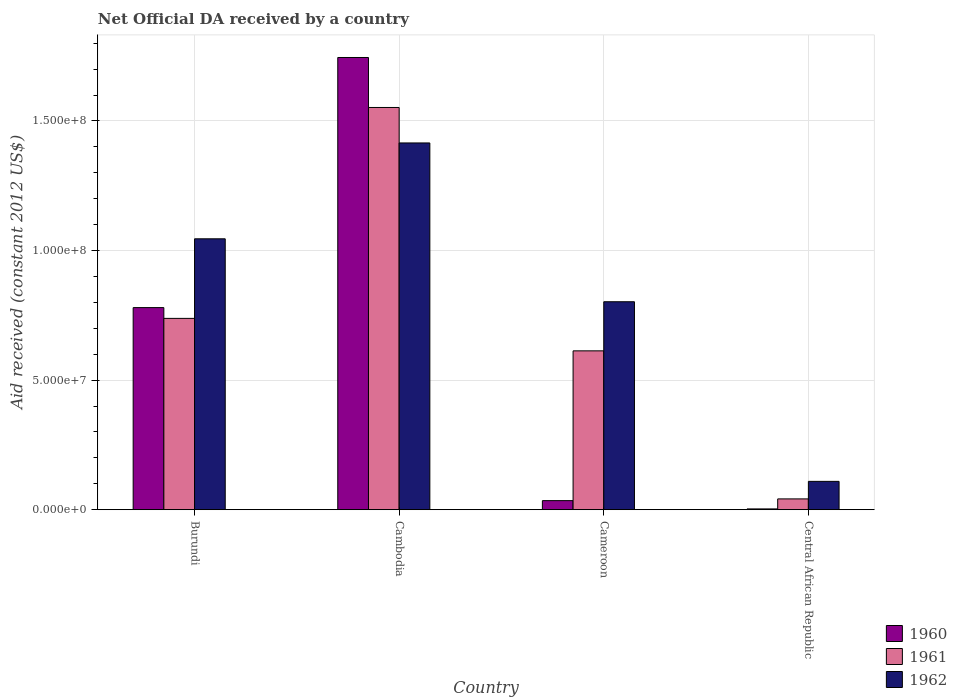Are the number of bars per tick equal to the number of legend labels?
Provide a short and direct response. Yes. What is the label of the 1st group of bars from the left?
Provide a short and direct response. Burundi. In how many cases, is the number of bars for a given country not equal to the number of legend labels?
Your answer should be compact. 0. What is the net official development assistance aid received in 1960 in Cambodia?
Make the answer very short. 1.75e+08. Across all countries, what is the maximum net official development assistance aid received in 1960?
Offer a very short reply. 1.75e+08. Across all countries, what is the minimum net official development assistance aid received in 1960?
Your answer should be compact. 3.00e+05. In which country was the net official development assistance aid received in 1960 maximum?
Offer a terse response. Cambodia. In which country was the net official development assistance aid received in 1962 minimum?
Give a very brief answer. Central African Republic. What is the total net official development assistance aid received in 1960 in the graph?
Your answer should be compact. 2.56e+08. What is the difference between the net official development assistance aid received in 1960 in Burundi and that in Cambodia?
Offer a very short reply. -9.65e+07. What is the difference between the net official development assistance aid received in 1961 in Cameroon and the net official development assistance aid received in 1960 in Burundi?
Your response must be concise. -1.67e+07. What is the average net official development assistance aid received in 1962 per country?
Offer a very short reply. 8.43e+07. What is the difference between the net official development assistance aid received of/in 1960 and net official development assistance aid received of/in 1962 in Central African Republic?
Provide a succinct answer. -1.06e+07. In how many countries, is the net official development assistance aid received in 1961 greater than 170000000 US$?
Ensure brevity in your answer.  0. What is the ratio of the net official development assistance aid received in 1961 in Cambodia to that in Cameroon?
Ensure brevity in your answer.  2.53. Is the net official development assistance aid received in 1962 in Cambodia less than that in Cameroon?
Provide a succinct answer. No. What is the difference between the highest and the second highest net official development assistance aid received in 1962?
Your answer should be very brief. 3.70e+07. What is the difference between the highest and the lowest net official development assistance aid received in 1962?
Your answer should be very brief. 1.31e+08. In how many countries, is the net official development assistance aid received in 1961 greater than the average net official development assistance aid received in 1961 taken over all countries?
Provide a short and direct response. 2. Is the sum of the net official development assistance aid received in 1961 in Burundi and Central African Republic greater than the maximum net official development assistance aid received in 1962 across all countries?
Offer a terse response. No. What does the 1st bar from the left in Central African Republic represents?
Provide a succinct answer. 1960. What does the 3rd bar from the right in Cambodia represents?
Offer a terse response. 1960. Are all the bars in the graph horizontal?
Provide a succinct answer. No. Are the values on the major ticks of Y-axis written in scientific E-notation?
Your answer should be very brief. Yes. Where does the legend appear in the graph?
Offer a terse response. Bottom right. How many legend labels are there?
Keep it short and to the point. 3. What is the title of the graph?
Provide a succinct answer. Net Official DA received by a country. What is the label or title of the X-axis?
Make the answer very short. Country. What is the label or title of the Y-axis?
Offer a terse response. Aid received (constant 2012 US$). What is the Aid received (constant 2012 US$) of 1960 in Burundi?
Keep it short and to the point. 7.80e+07. What is the Aid received (constant 2012 US$) in 1961 in Burundi?
Make the answer very short. 7.38e+07. What is the Aid received (constant 2012 US$) in 1962 in Burundi?
Offer a very short reply. 1.05e+08. What is the Aid received (constant 2012 US$) in 1960 in Cambodia?
Offer a terse response. 1.75e+08. What is the Aid received (constant 2012 US$) in 1961 in Cambodia?
Your answer should be compact. 1.55e+08. What is the Aid received (constant 2012 US$) in 1962 in Cambodia?
Give a very brief answer. 1.42e+08. What is the Aid received (constant 2012 US$) of 1960 in Cameroon?
Keep it short and to the point. 3.50e+06. What is the Aid received (constant 2012 US$) in 1961 in Cameroon?
Keep it short and to the point. 6.13e+07. What is the Aid received (constant 2012 US$) of 1962 in Cameroon?
Keep it short and to the point. 8.02e+07. What is the Aid received (constant 2012 US$) of 1961 in Central African Republic?
Keep it short and to the point. 4.17e+06. What is the Aid received (constant 2012 US$) of 1962 in Central African Republic?
Your response must be concise. 1.09e+07. Across all countries, what is the maximum Aid received (constant 2012 US$) of 1960?
Your response must be concise. 1.75e+08. Across all countries, what is the maximum Aid received (constant 2012 US$) of 1961?
Give a very brief answer. 1.55e+08. Across all countries, what is the maximum Aid received (constant 2012 US$) of 1962?
Your answer should be very brief. 1.42e+08. Across all countries, what is the minimum Aid received (constant 2012 US$) of 1960?
Provide a succinct answer. 3.00e+05. Across all countries, what is the minimum Aid received (constant 2012 US$) of 1961?
Give a very brief answer. 4.17e+06. Across all countries, what is the minimum Aid received (constant 2012 US$) in 1962?
Offer a very short reply. 1.09e+07. What is the total Aid received (constant 2012 US$) of 1960 in the graph?
Your answer should be compact. 2.56e+08. What is the total Aid received (constant 2012 US$) of 1961 in the graph?
Keep it short and to the point. 2.95e+08. What is the total Aid received (constant 2012 US$) of 1962 in the graph?
Offer a terse response. 3.37e+08. What is the difference between the Aid received (constant 2012 US$) of 1960 in Burundi and that in Cambodia?
Offer a very short reply. -9.65e+07. What is the difference between the Aid received (constant 2012 US$) in 1961 in Burundi and that in Cambodia?
Give a very brief answer. -8.14e+07. What is the difference between the Aid received (constant 2012 US$) in 1962 in Burundi and that in Cambodia?
Your answer should be very brief. -3.70e+07. What is the difference between the Aid received (constant 2012 US$) in 1960 in Burundi and that in Cameroon?
Offer a very short reply. 7.45e+07. What is the difference between the Aid received (constant 2012 US$) of 1961 in Burundi and that in Cameroon?
Keep it short and to the point. 1.25e+07. What is the difference between the Aid received (constant 2012 US$) in 1962 in Burundi and that in Cameroon?
Provide a succinct answer. 2.43e+07. What is the difference between the Aid received (constant 2012 US$) in 1960 in Burundi and that in Central African Republic?
Your response must be concise. 7.77e+07. What is the difference between the Aid received (constant 2012 US$) of 1961 in Burundi and that in Central African Republic?
Offer a terse response. 6.97e+07. What is the difference between the Aid received (constant 2012 US$) in 1962 in Burundi and that in Central African Republic?
Offer a terse response. 9.36e+07. What is the difference between the Aid received (constant 2012 US$) in 1960 in Cambodia and that in Cameroon?
Your answer should be very brief. 1.71e+08. What is the difference between the Aid received (constant 2012 US$) in 1961 in Cambodia and that in Cameroon?
Offer a very short reply. 9.39e+07. What is the difference between the Aid received (constant 2012 US$) in 1962 in Cambodia and that in Cameroon?
Provide a succinct answer. 6.13e+07. What is the difference between the Aid received (constant 2012 US$) of 1960 in Cambodia and that in Central African Republic?
Offer a very short reply. 1.74e+08. What is the difference between the Aid received (constant 2012 US$) of 1961 in Cambodia and that in Central African Republic?
Offer a terse response. 1.51e+08. What is the difference between the Aid received (constant 2012 US$) of 1962 in Cambodia and that in Central African Republic?
Give a very brief answer. 1.31e+08. What is the difference between the Aid received (constant 2012 US$) in 1960 in Cameroon and that in Central African Republic?
Your response must be concise. 3.20e+06. What is the difference between the Aid received (constant 2012 US$) of 1961 in Cameroon and that in Central African Republic?
Your answer should be compact. 5.71e+07. What is the difference between the Aid received (constant 2012 US$) of 1962 in Cameroon and that in Central African Republic?
Ensure brevity in your answer.  6.93e+07. What is the difference between the Aid received (constant 2012 US$) of 1960 in Burundi and the Aid received (constant 2012 US$) of 1961 in Cambodia?
Make the answer very short. -7.72e+07. What is the difference between the Aid received (constant 2012 US$) of 1960 in Burundi and the Aid received (constant 2012 US$) of 1962 in Cambodia?
Keep it short and to the point. -6.35e+07. What is the difference between the Aid received (constant 2012 US$) in 1961 in Burundi and the Aid received (constant 2012 US$) in 1962 in Cambodia?
Ensure brevity in your answer.  -6.77e+07. What is the difference between the Aid received (constant 2012 US$) in 1960 in Burundi and the Aid received (constant 2012 US$) in 1961 in Cameroon?
Your response must be concise. 1.67e+07. What is the difference between the Aid received (constant 2012 US$) in 1960 in Burundi and the Aid received (constant 2012 US$) in 1962 in Cameroon?
Offer a very short reply. -2.26e+06. What is the difference between the Aid received (constant 2012 US$) in 1961 in Burundi and the Aid received (constant 2012 US$) in 1962 in Cameroon?
Give a very brief answer. -6.42e+06. What is the difference between the Aid received (constant 2012 US$) of 1960 in Burundi and the Aid received (constant 2012 US$) of 1961 in Central African Republic?
Ensure brevity in your answer.  7.38e+07. What is the difference between the Aid received (constant 2012 US$) of 1960 in Burundi and the Aid received (constant 2012 US$) of 1962 in Central African Republic?
Your answer should be compact. 6.71e+07. What is the difference between the Aid received (constant 2012 US$) in 1961 in Burundi and the Aid received (constant 2012 US$) in 1962 in Central African Republic?
Ensure brevity in your answer.  6.29e+07. What is the difference between the Aid received (constant 2012 US$) of 1960 in Cambodia and the Aid received (constant 2012 US$) of 1961 in Cameroon?
Your answer should be compact. 1.13e+08. What is the difference between the Aid received (constant 2012 US$) of 1960 in Cambodia and the Aid received (constant 2012 US$) of 1962 in Cameroon?
Offer a very short reply. 9.43e+07. What is the difference between the Aid received (constant 2012 US$) in 1961 in Cambodia and the Aid received (constant 2012 US$) in 1962 in Cameroon?
Offer a terse response. 7.50e+07. What is the difference between the Aid received (constant 2012 US$) of 1960 in Cambodia and the Aid received (constant 2012 US$) of 1961 in Central African Republic?
Make the answer very short. 1.70e+08. What is the difference between the Aid received (constant 2012 US$) in 1960 in Cambodia and the Aid received (constant 2012 US$) in 1962 in Central African Republic?
Provide a succinct answer. 1.64e+08. What is the difference between the Aid received (constant 2012 US$) in 1961 in Cambodia and the Aid received (constant 2012 US$) in 1962 in Central African Republic?
Your answer should be compact. 1.44e+08. What is the difference between the Aid received (constant 2012 US$) of 1960 in Cameroon and the Aid received (constant 2012 US$) of 1961 in Central African Republic?
Your answer should be very brief. -6.70e+05. What is the difference between the Aid received (constant 2012 US$) in 1960 in Cameroon and the Aid received (constant 2012 US$) in 1962 in Central African Republic?
Ensure brevity in your answer.  -7.43e+06. What is the difference between the Aid received (constant 2012 US$) in 1961 in Cameroon and the Aid received (constant 2012 US$) in 1962 in Central African Republic?
Provide a succinct answer. 5.04e+07. What is the average Aid received (constant 2012 US$) of 1960 per country?
Keep it short and to the point. 6.41e+07. What is the average Aid received (constant 2012 US$) in 1961 per country?
Your response must be concise. 7.36e+07. What is the average Aid received (constant 2012 US$) in 1962 per country?
Give a very brief answer. 8.43e+07. What is the difference between the Aid received (constant 2012 US$) in 1960 and Aid received (constant 2012 US$) in 1961 in Burundi?
Your response must be concise. 4.16e+06. What is the difference between the Aid received (constant 2012 US$) of 1960 and Aid received (constant 2012 US$) of 1962 in Burundi?
Make the answer very short. -2.66e+07. What is the difference between the Aid received (constant 2012 US$) of 1961 and Aid received (constant 2012 US$) of 1962 in Burundi?
Give a very brief answer. -3.07e+07. What is the difference between the Aid received (constant 2012 US$) in 1960 and Aid received (constant 2012 US$) in 1961 in Cambodia?
Offer a very short reply. 1.93e+07. What is the difference between the Aid received (constant 2012 US$) in 1960 and Aid received (constant 2012 US$) in 1962 in Cambodia?
Make the answer very short. 3.30e+07. What is the difference between the Aid received (constant 2012 US$) in 1961 and Aid received (constant 2012 US$) in 1962 in Cambodia?
Provide a short and direct response. 1.37e+07. What is the difference between the Aid received (constant 2012 US$) in 1960 and Aid received (constant 2012 US$) in 1961 in Cameroon?
Provide a short and direct response. -5.78e+07. What is the difference between the Aid received (constant 2012 US$) in 1960 and Aid received (constant 2012 US$) in 1962 in Cameroon?
Your answer should be compact. -7.68e+07. What is the difference between the Aid received (constant 2012 US$) of 1961 and Aid received (constant 2012 US$) of 1962 in Cameroon?
Ensure brevity in your answer.  -1.90e+07. What is the difference between the Aid received (constant 2012 US$) in 1960 and Aid received (constant 2012 US$) in 1961 in Central African Republic?
Give a very brief answer. -3.87e+06. What is the difference between the Aid received (constant 2012 US$) of 1960 and Aid received (constant 2012 US$) of 1962 in Central African Republic?
Your answer should be very brief. -1.06e+07. What is the difference between the Aid received (constant 2012 US$) in 1961 and Aid received (constant 2012 US$) in 1962 in Central African Republic?
Provide a short and direct response. -6.76e+06. What is the ratio of the Aid received (constant 2012 US$) in 1960 in Burundi to that in Cambodia?
Give a very brief answer. 0.45. What is the ratio of the Aid received (constant 2012 US$) in 1961 in Burundi to that in Cambodia?
Make the answer very short. 0.48. What is the ratio of the Aid received (constant 2012 US$) of 1962 in Burundi to that in Cambodia?
Keep it short and to the point. 0.74. What is the ratio of the Aid received (constant 2012 US$) in 1960 in Burundi to that in Cameroon?
Make the answer very short. 22.28. What is the ratio of the Aid received (constant 2012 US$) of 1961 in Burundi to that in Cameroon?
Your response must be concise. 1.2. What is the ratio of the Aid received (constant 2012 US$) in 1962 in Burundi to that in Cameroon?
Your answer should be compact. 1.3. What is the ratio of the Aid received (constant 2012 US$) in 1960 in Burundi to that in Central African Republic?
Provide a short and direct response. 259.97. What is the ratio of the Aid received (constant 2012 US$) in 1961 in Burundi to that in Central African Republic?
Offer a very short reply. 17.7. What is the ratio of the Aid received (constant 2012 US$) in 1962 in Burundi to that in Central African Republic?
Provide a short and direct response. 9.56. What is the ratio of the Aid received (constant 2012 US$) of 1960 in Cambodia to that in Cameroon?
Give a very brief answer. 49.86. What is the ratio of the Aid received (constant 2012 US$) in 1961 in Cambodia to that in Cameroon?
Keep it short and to the point. 2.53. What is the ratio of the Aid received (constant 2012 US$) of 1962 in Cambodia to that in Cameroon?
Provide a succinct answer. 1.76. What is the ratio of the Aid received (constant 2012 US$) of 1960 in Cambodia to that in Central African Republic?
Ensure brevity in your answer.  581.7. What is the ratio of the Aid received (constant 2012 US$) of 1961 in Cambodia to that in Central African Republic?
Make the answer very short. 37.22. What is the ratio of the Aid received (constant 2012 US$) in 1962 in Cambodia to that in Central African Republic?
Your response must be concise. 12.95. What is the ratio of the Aid received (constant 2012 US$) in 1960 in Cameroon to that in Central African Republic?
Give a very brief answer. 11.67. What is the ratio of the Aid received (constant 2012 US$) in 1961 in Cameroon to that in Central African Republic?
Your response must be concise. 14.7. What is the ratio of the Aid received (constant 2012 US$) of 1962 in Cameroon to that in Central African Republic?
Your response must be concise. 7.34. What is the difference between the highest and the second highest Aid received (constant 2012 US$) of 1960?
Ensure brevity in your answer.  9.65e+07. What is the difference between the highest and the second highest Aid received (constant 2012 US$) of 1961?
Your answer should be compact. 8.14e+07. What is the difference between the highest and the second highest Aid received (constant 2012 US$) in 1962?
Your response must be concise. 3.70e+07. What is the difference between the highest and the lowest Aid received (constant 2012 US$) in 1960?
Your answer should be compact. 1.74e+08. What is the difference between the highest and the lowest Aid received (constant 2012 US$) of 1961?
Make the answer very short. 1.51e+08. What is the difference between the highest and the lowest Aid received (constant 2012 US$) in 1962?
Provide a short and direct response. 1.31e+08. 